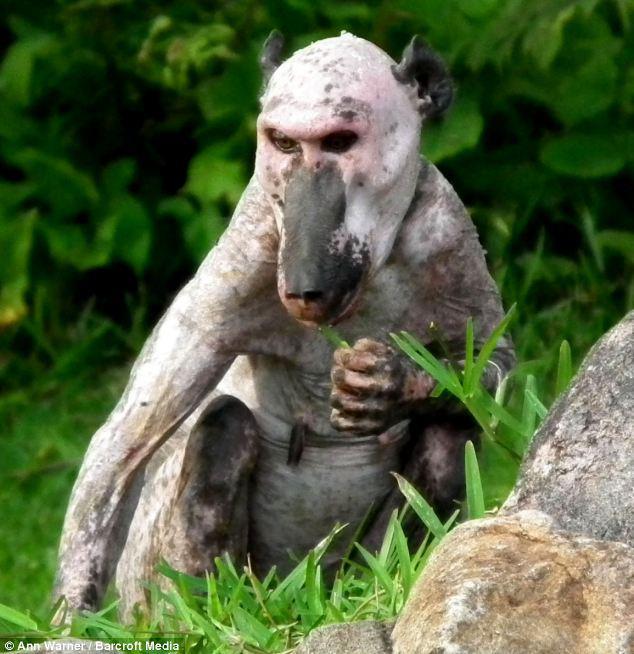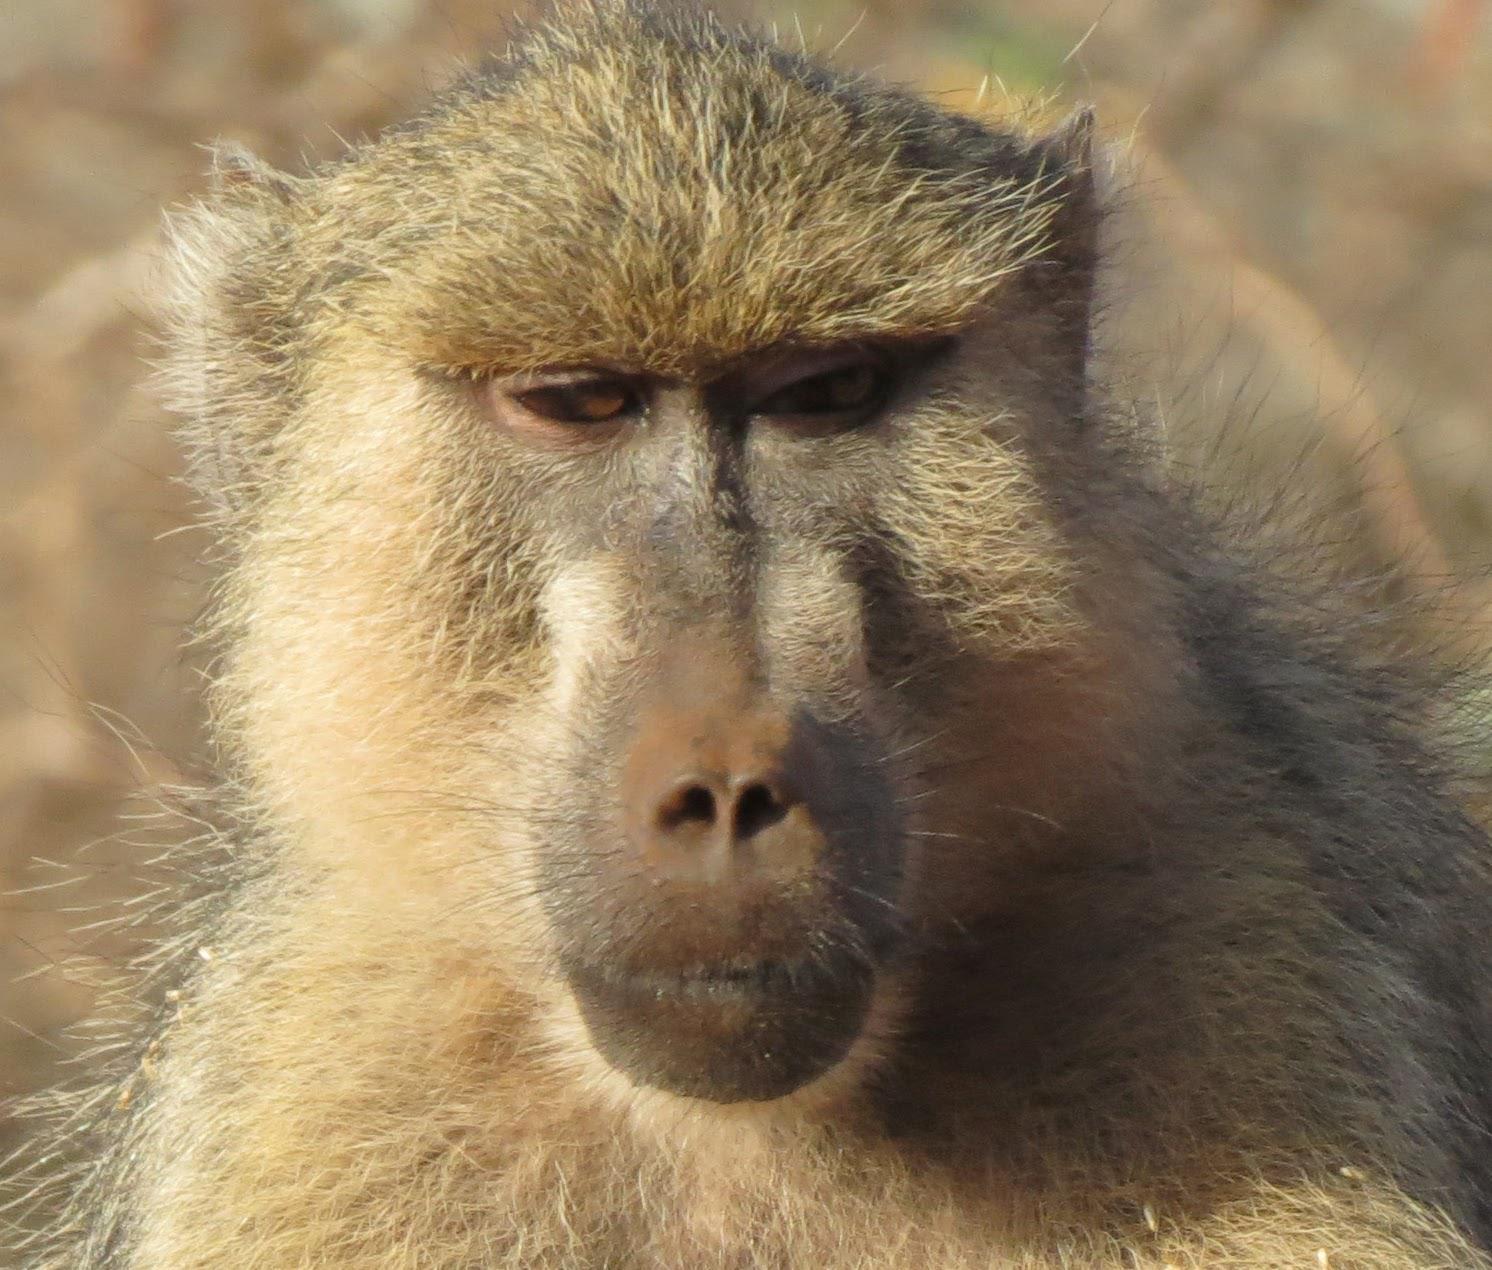The first image is the image on the left, the second image is the image on the right. Considering the images on both sides, is "A total of four monkeys are shown." valid? Answer yes or no. No. 